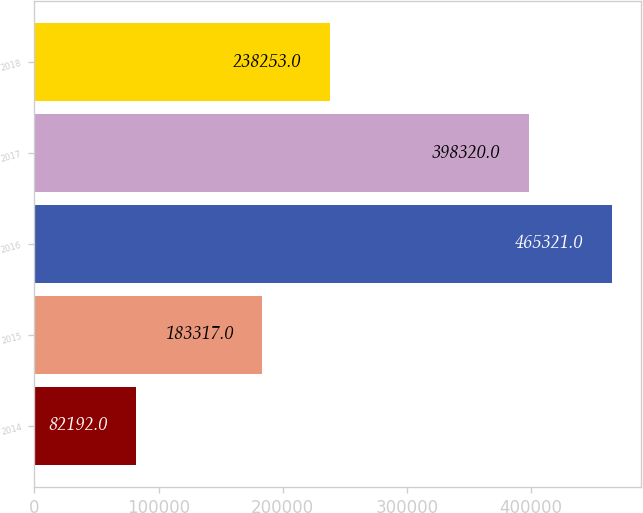Convert chart to OTSL. <chart><loc_0><loc_0><loc_500><loc_500><bar_chart><fcel>2014<fcel>2015<fcel>2016<fcel>2017<fcel>2018<nl><fcel>82192<fcel>183317<fcel>465321<fcel>398320<fcel>238253<nl></chart> 